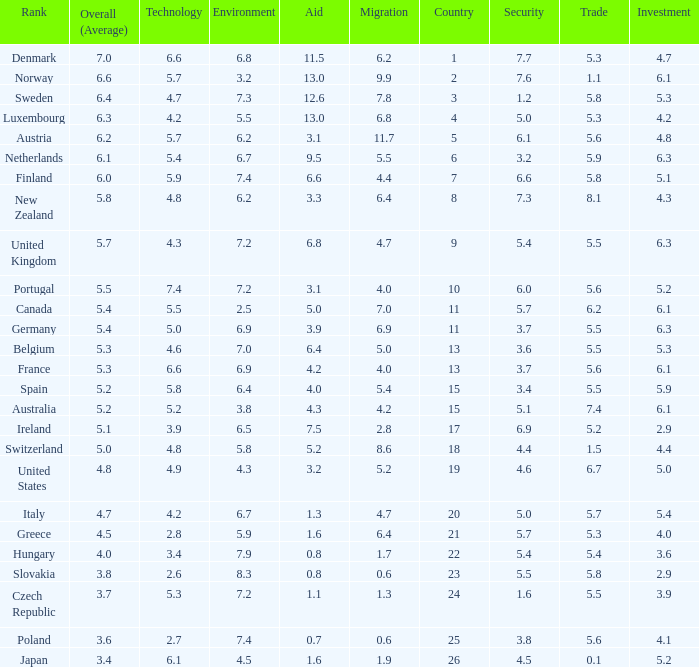How many times is denmark ranked in technology? 1.0. 